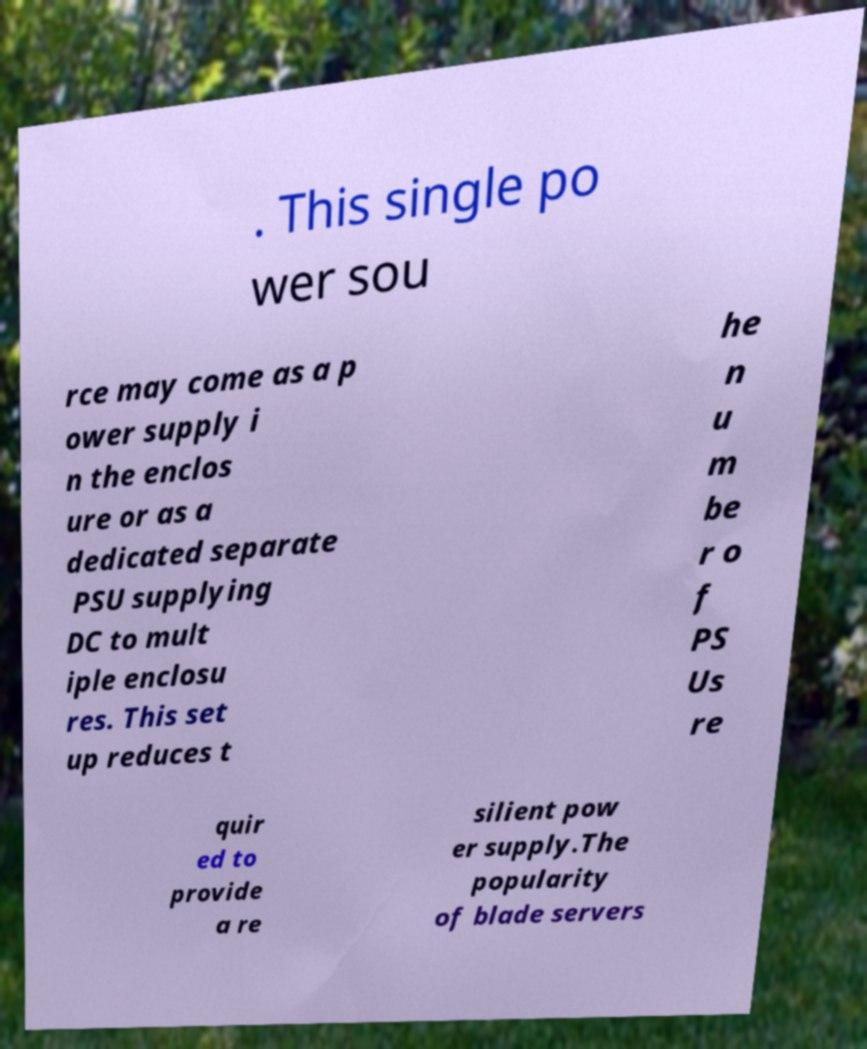There's text embedded in this image that I need extracted. Can you transcribe it verbatim? . This single po wer sou rce may come as a p ower supply i n the enclos ure or as a dedicated separate PSU supplying DC to mult iple enclosu res. This set up reduces t he n u m be r o f PS Us re quir ed to provide a re silient pow er supply.The popularity of blade servers 